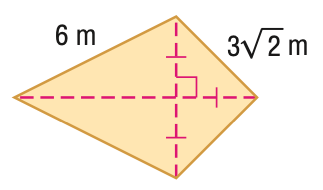Answer the mathemtical geometry problem and directly provide the correct option letter.
Question: Find the perimeter of the figure in feet. Round to the nearest tenth, if necessary.
Choices: A: 20.5 B: 21 C: 22.4 D: 24 A 